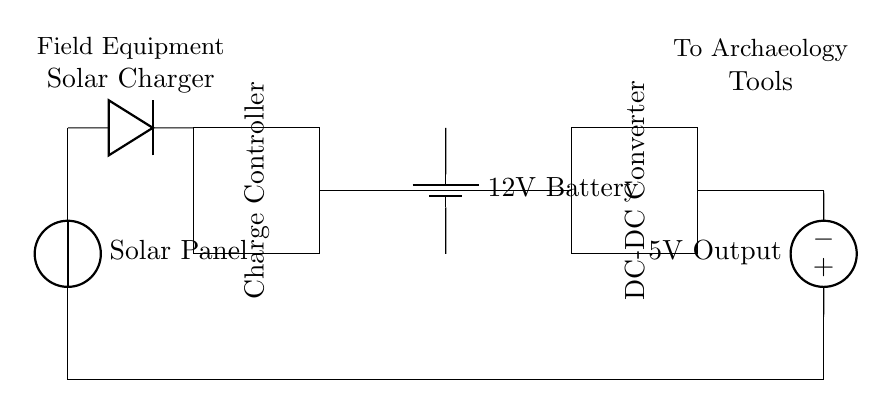What component generates the power in this circuit? The component that generates power in the circuit is the solar panel, which converts sunlight into electrical energy.
Answer: Solar Panel What is the purpose of the diode in this circuit? The diode prevents current from flowing back into the solar panel, ensuring that the energy flows in the correct direction to charge the battery.
Answer: Prevents backflow What is the voltage rating of the battery? The battery has a voltage rating of 12 volts, which is necessary for storing energy generated by the solar panel.
Answer: 12 volts What is the output voltage of the circuit? The output voltage from the circuit is 5 volts, which is regulated by the DC-DC converter to match the needs of the field equipment.
Answer: 5 volts Why is a charge controller used in the circuit? The charge controller manages the voltage and current coming from the solar panel to prevent overcharging of the battery, thus protecting its lifespan.
Answer: Prevents overcharging How many components are involved in the solar charger circuit? There are five main components in this circuit: a solar panel, diode, charge controller, battery, and DC-DC converter.
Answer: Five components 